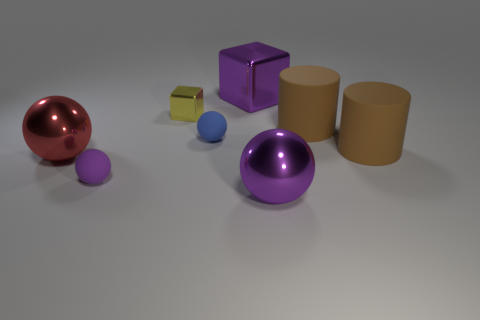Subtract 1 balls. How many balls are left? 3 Add 1 gray blocks. How many objects exist? 9 Subtract all cubes. How many objects are left? 6 Subtract 0 gray cylinders. How many objects are left? 8 Subtract all red spheres. Subtract all tiny blue matte things. How many objects are left? 6 Add 1 small blocks. How many small blocks are left? 2 Add 7 red spheres. How many red spheres exist? 8 